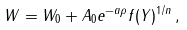Convert formula to latex. <formula><loc_0><loc_0><loc_500><loc_500>W = W _ { 0 } + A _ { 0 } e ^ { - a \rho } f ( Y ) ^ { 1 / n } \, ,</formula> 